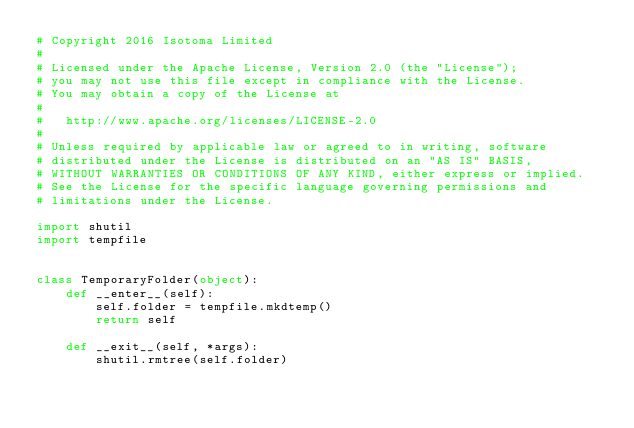<code> <loc_0><loc_0><loc_500><loc_500><_Python_># Copyright 2016 Isotoma Limited
#
# Licensed under the Apache License, Version 2.0 (the "License");
# you may not use this file except in compliance with the License.
# You may obtain a copy of the License at
#
#   http://www.apache.org/licenses/LICENSE-2.0
#
# Unless required by applicable law or agreed to in writing, software
# distributed under the License is distributed on an "AS IS" BASIS,
# WITHOUT WARRANTIES OR CONDITIONS OF ANY KIND, either express or implied.
# See the License for the specific language governing permissions and
# limitations under the License.

import shutil
import tempfile


class TemporaryFolder(object):
    def __enter__(self):
        self.folder = tempfile.mkdtemp()
        return self

    def __exit__(self, *args):
        shutil.rmtree(self.folder)
</code> 